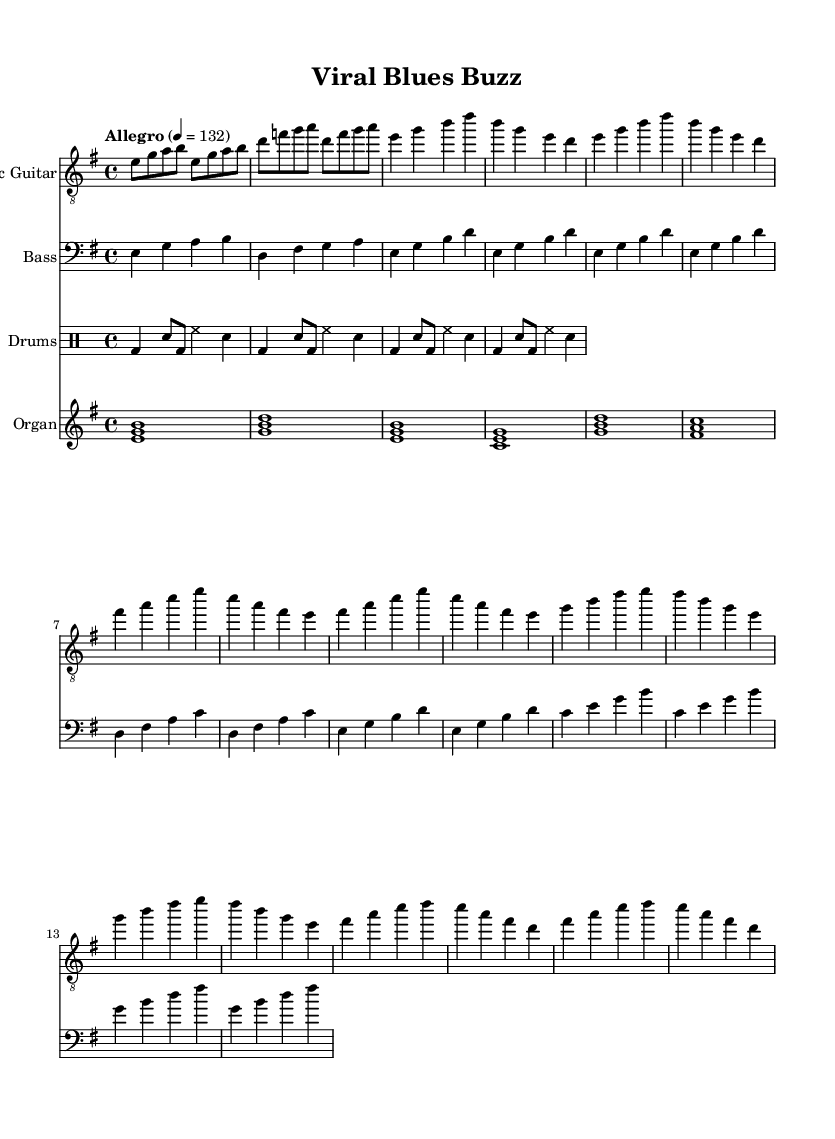What is the key signature of this music? The key signature is E minor, which has one sharp (F#) indicated on the staff.
Answer: E minor What is the time signature of this piece? The time signature shown in the sheet music indicates 4/4, which means there are four beats in each measure and the quarter note receives one beat.
Answer: 4/4 What is the tempo marking for this music? The tempo marking is "Allegro," which denotes a fast and lively pace, specifically indicated as 4 equals 132 beats per minute.
Answer: Allegro How many verses are included in the structure? The sheet music shows two repeat sections of the verse material, suggesting there are two verses in total, as the sections repeat the same musical phrase.
Answer: Two What is the primary instrument used for the melody in this piece? The Electric Guitar is the primary instrument used for the melody, as indicated by its staff notation and the melodic content that is predominantly presented in this section.
Answer: Electric Guitar How do the bass and drums contribute to the overall rhythm? The bass provides a foundation by outlining chord changes and rhythmic support while the drums deliver a consistent rock beat, emphasizing the backbeat with bass drums and snare. This combination creates a strong rhythmic base for the piece, essential to electric blues.
Answer: Strong rhythmic base What type of musical form is evident in this electric blues piece? The sheet music indicates a typical verse-chorus structure, where verses alternate with the chorus, a common form in electric blues songs that enhances thematic development and audience engagement.
Answer: Verse-Chorus form 